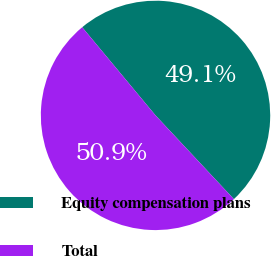Convert chart to OTSL. <chart><loc_0><loc_0><loc_500><loc_500><pie_chart><fcel>Equity compensation plans<fcel>Total<nl><fcel>49.07%<fcel>50.93%<nl></chart> 